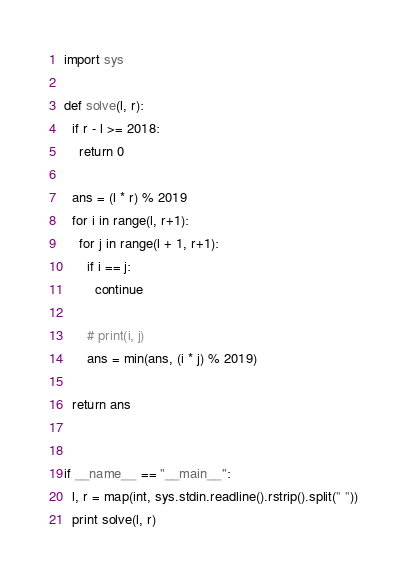<code> <loc_0><loc_0><loc_500><loc_500><_Python_>import sys

def solve(l, r):
  if r - l >= 2018:
    return 0

  ans = (l * r) % 2019
  for i in range(l, r+1):
    for j in range(l + 1, r+1):
      if i == j:
        continue

      # print(i, j)
      ans = min(ans, (i * j) % 2019)

  return ans


if __name__ == "__main__":
  l, r = map(int, sys.stdin.readline().rstrip().split(" "))
  print solve(l, r)</code> 